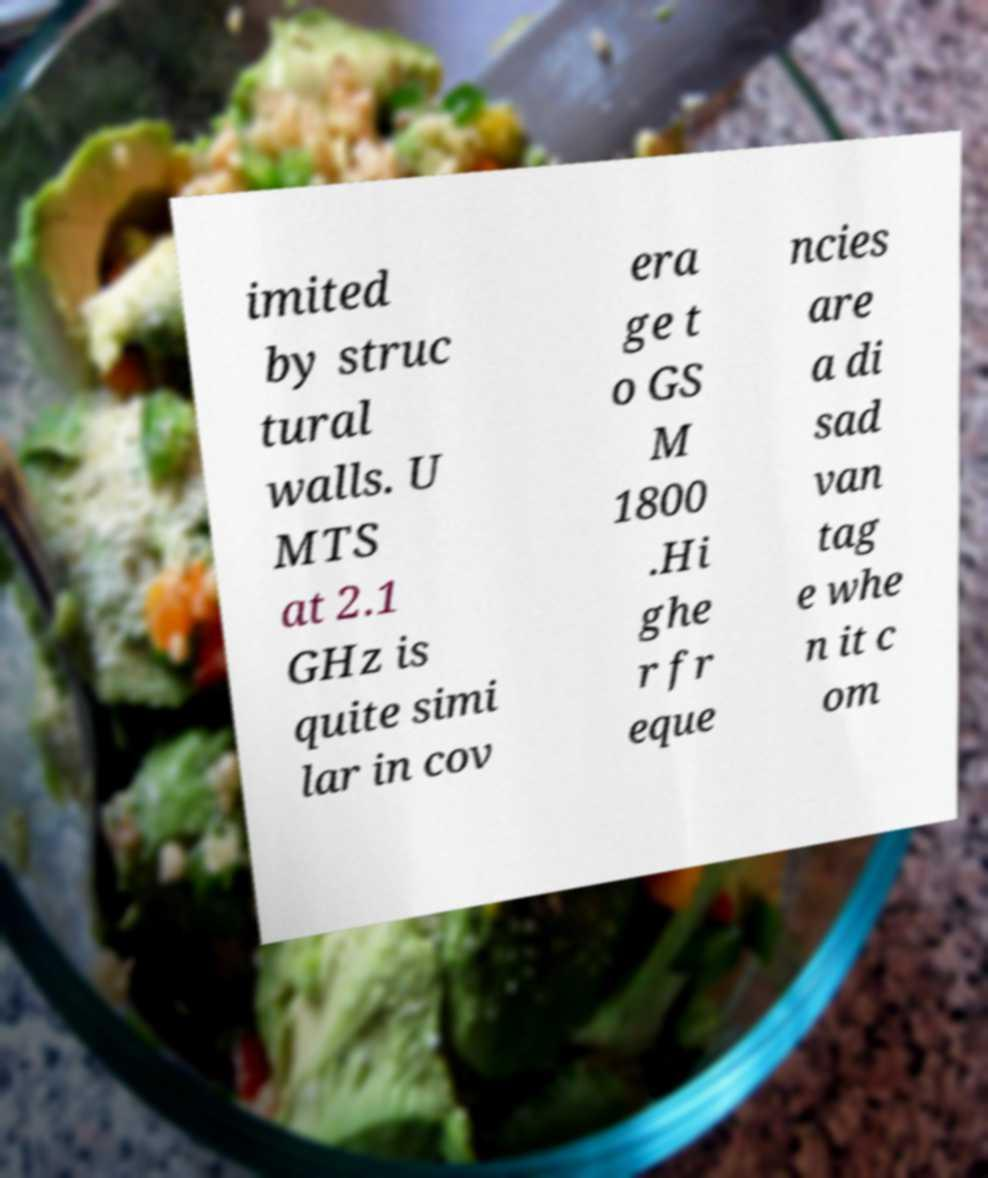Could you assist in decoding the text presented in this image and type it out clearly? imited by struc tural walls. U MTS at 2.1 GHz is quite simi lar in cov era ge t o GS M 1800 .Hi ghe r fr eque ncies are a di sad van tag e whe n it c om 